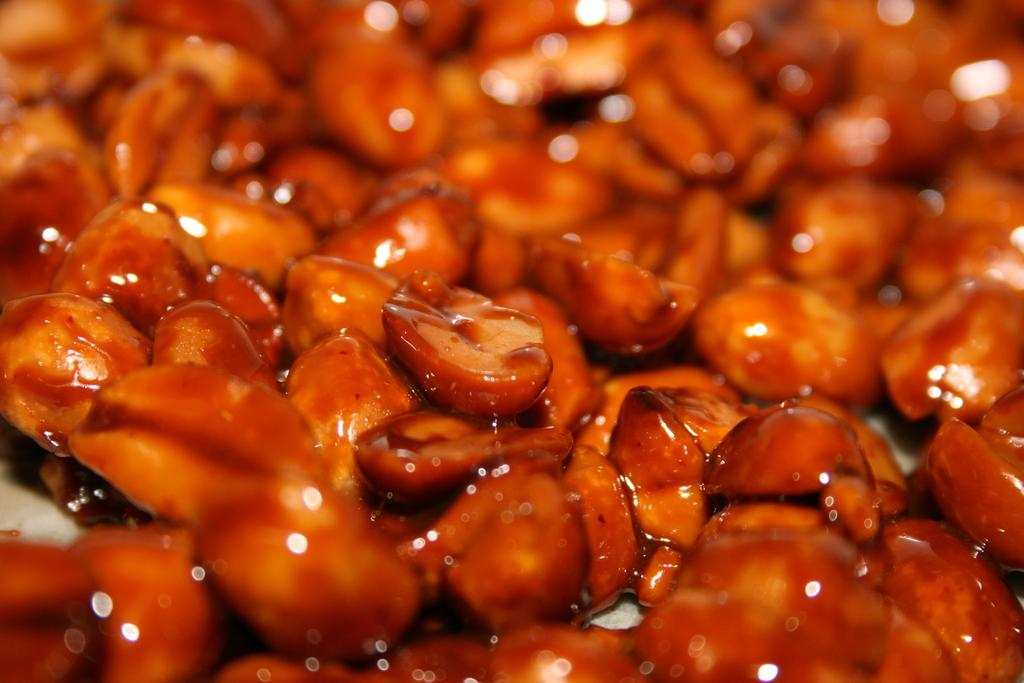What type of food is visible in the image? There are caramelized peanuts in the image. Can you describe the background of the image? The background of the image is blurred. What type of bells can be heard ringing in the image? There are no bells present in the image, and therefore no sounds can be heard. What type of structure is visible in the image? There is no structure visible in the image; it only features caramelized peanuts. What type of beast is present in the image? There is no beast present in the image; it only features caramelized peanuts. 